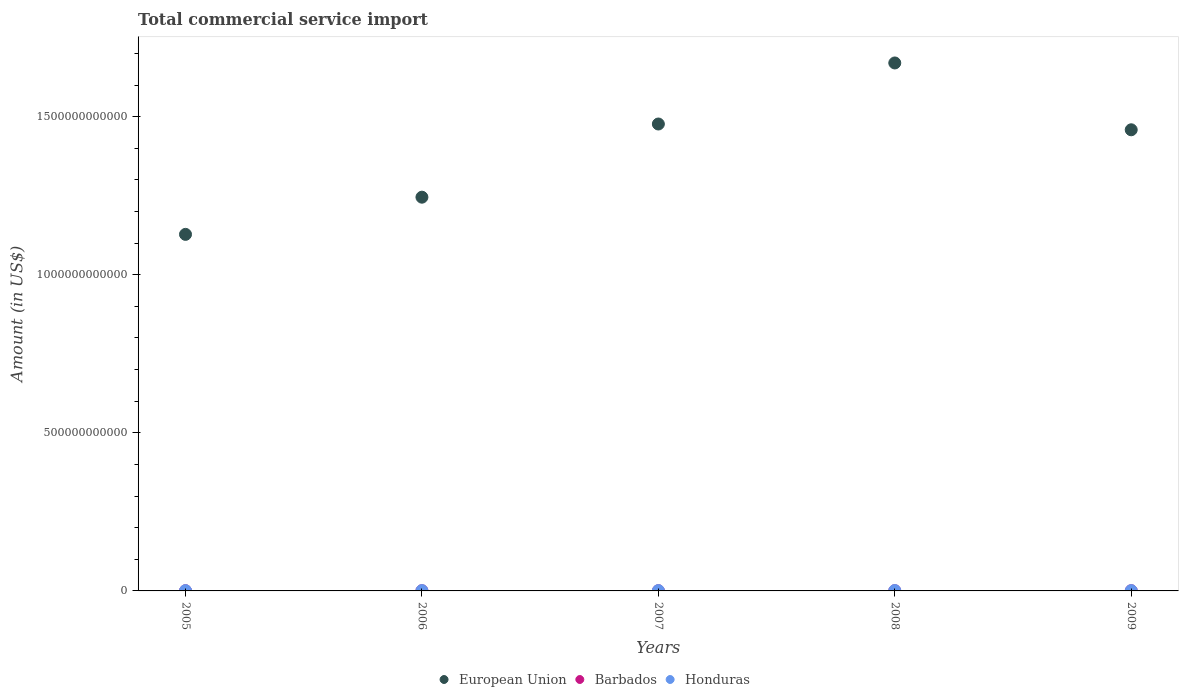What is the total commercial service import in Barbados in 2006?
Your response must be concise. 6.43e+08. Across all years, what is the maximum total commercial service import in European Union?
Ensure brevity in your answer.  1.67e+12. Across all years, what is the minimum total commercial service import in European Union?
Offer a terse response. 1.13e+12. What is the total total commercial service import in Barbados in the graph?
Your answer should be very brief. 3.22e+09. What is the difference between the total commercial service import in European Union in 2007 and that in 2009?
Your answer should be very brief. 1.83e+1. What is the difference between the total commercial service import in Honduras in 2006 and the total commercial service import in Barbados in 2007?
Offer a terse response. 4.20e+08. What is the average total commercial service import in Honduras per year?
Your response must be concise. 1.03e+09. In the year 2008, what is the difference between the total commercial service import in European Union and total commercial service import in Honduras?
Ensure brevity in your answer.  1.67e+12. What is the ratio of the total commercial service import in Honduras in 2008 to that in 2009?
Your response must be concise. 1.29. Is the total commercial service import in European Union in 2006 less than that in 2009?
Give a very brief answer. Yes. What is the difference between the highest and the second highest total commercial service import in Barbados?
Keep it short and to the point. 4.85e+07. What is the difference between the highest and the lowest total commercial service import in European Union?
Offer a very short reply. 5.42e+11. In how many years, is the total commercial service import in Barbados greater than the average total commercial service import in Barbados taken over all years?
Offer a terse response. 2. Is the sum of the total commercial service import in Barbados in 2007 and 2008 greater than the maximum total commercial service import in European Union across all years?
Make the answer very short. No. Is it the case that in every year, the sum of the total commercial service import in European Union and total commercial service import in Barbados  is greater than the total commercial service import in Honduras?
Make the answer very short. Yes. Does the total commercial service import in European Union monotonically increase over the years?
Offer a very short reply. No. Is the total commercial service import in European Union strictly greater than the total commercial service import in Barbados over the years?
Provide a short and direct response. Yes. Is the total commercial service import in Barbados strictly less than the total commercial service import in European Union over the years?
Your response must be concise. Yes. How many years are there in the graph?
Provide a succinct answer. 5. What is the difference between two consecutive major ticks on the Y-axis?
Give a very brief answer. 5.00e+11. What is the title of the graph?
Offer a terse response. Total commercial service import. What is the label or title of the X-axis?
Make the answer very short. Years. What is the label or title of the Y-axis?
Keep it short and to the point. Amount (in US$). What is the Amount (in US$) in European Union in 2005?
Make the answer very short. 1.13e+12. What is the Amount (in US$) of Barbados in 2005?
Ensure brevity in your answer.  6.15e+08. What is the Amount (in US$) of Honduras in 2005?
Provide a succinct answer. 9.24e+08. What is the Amount (in US$) in European Union in 2006?
Your answer should be compact. 1.25e+12. What is the Amount (in US$) in Barbados in 2006?
Offer a very short reply. 6.43e+08. What is the Amount (in US$) of Honduras in 2006?
Keep it short and to the point. 1.03e+09. What is the Amount (in US$) in European Union in 2007?
Ensure brevity in your answer.  1.48e+12. What is the Amount (in US$) of Barbados in 2007?
Offer a very short reply. 6.07e+08. What is the Amount (in US$) in Honduras in 2007?
Offer a very short reply. 1.06e+09. What is the Amount (in US$) of European Union in 2008?
Provide a short and direct response. 1.67e+12. What is the Amount (in US$) of Barbados in 2008?
Provide a short and direct response. 7.00e+08. What is the Amount (in US$) in Honduras in 2008?
Ensure brevity in your answer.  1.21e+09. What is the Amount (in US$) in European Union in 2009?
Keep it short and to the point. 1.46e+12. What is the Amount (in US$) in Barbados in 2009?
Your response must be concise. 6.52e+08. What is the Amount (in US$) of Honduras in 2009?
Offer a terse response. 9.42e+08. Across all years, what is the maximum Amount (in US$) of European Union?
Make the answer very short. 1.67e+12. Across all years, what is the maximum Amount (in US$) in Barbados?
Your response must be concise. 7.00e+08. Across all years, what is the maximum Amount (in US$) of Honduras?
Offer a terse response. 1.21e+09. Across all years, what is the minimum Amount (in US$) of European Union?
Offer a terse response. 1.13e+12. Across all years, what is the minimum Amount (in US$) in Barbados?
Your response must be concise. 6.07e+08. Across all years, what is the minimum Amount (in US$) in Honduras?
Ensure brevity in your answer.  9.24e+08. What is the total Amount (in US$) in European Union in the graph?
Offer a terse response. 6.98e+12. What is the total Amount (in US$) of Barbados in the graph?
Ensure brevity in your answer.  3.22e+09. What is the total Amount (in US$) in Honduras in the graph?
Ensure brevity in your answer.  5.16e+09. What is the difference between the Amount (in US$) in European Union in 2005 and that in 2006?
Make the answer very short. -1.18e+11. What is the difference between the Amount (in US$) of Barbados in 2005 and that in 2006?
Offer a terse response. -2.82e+07. What is the difference between the Amount (in US$) of Honduras in 2005 and that in 2006?
Keep it short and to the point. -1.03e+08. What is the difference between the Amount (in US$) of European Union in 2005 and that in 2007?
Your response must be concise. -3.49e+11. What is the difference between the Amount (in US$) of Barbados in 2005 and that in 2007?
Keep it short and to the point. 7.79e+06. What is the difference between the Amount (in US$) of Honduras in 2005 and that in 2007?
Provide a short and direct response. -1.34e+08. What is the difference between the Amount (in US$) in European Union in 2005 and that in 2008?
Offer a terse response. -5.42e+11. What is the difference between the Amount (in US$) in Barbados in 2005 and that in 2008?
Your response must be concise. -8.54e+07. What is the difference between the Amount (in US$) in Honduras in 2005 and that in 2008?
Ensure brevity in your answer.  -2.90e+08. What is the difference between the Amount (in US$) in European Union in 2005 and that in 2009?
Offer a very short reply. -3.31e+11. What is the difference between the Amount (in US$) of Barbados in 2005 and that in 2009?
Your response must be concise. -3.69e+07. What is the difference between the Amount (in US$) of Honduras in 2005 and that in 2009?
Provide a short and direct response. -1.88e+07. What is the difference between the Amount (in US$) in European Union in 2006 and that in 2007?
Give a very brief answer. -2.31e+11. What is the difference between the Amount (in US$) in Barbados in 2006 and that in 2007?
Give a very brief answer. 3.60e+07. What is the difference between the Amount (in US$) in Honduras in 2006 and that in 2007?
Provide a short and direct response. -3.11e+07. What is the difference between the Amount (in US$) of European Union in 2006 and that in 2008?
Offer a terse response. -4.25e+11. What is the difference between the Amount (in US$) of Barbados in 2006 and that in 2008?
Your answer should be compact. -5.72e+07. What is the difference between the Amount (in US$) in Honduras in 2006 and that in 2008?
Your answer should be compact. -1.86e+08. What is the difference between the Amount (in US$) in European Union in 2006 and that in 2009?
Give a very brief answer. -2.13e+11. What is the difference between the Amount (in US$) in Barbados in 2006 and that in 2009?
Your answer should be very brief. -8.71e+06. What is the difference between the Amount (in US$) of Honduras in 2006 and that in 2009?
Ensure brevity in your answer.  8.46e+07. What is the difference between the Amount (in US$) of European Union in 2007 and that in 2008?
Provide a succinct answer. -1.93e+11. What is the difference between the Amount (in US$) in Barbados in 2007 and that in 2008?
Provide a short and direct response. -9.32e+07. What is the difference between the Amount (in US$) in Honduras in 2007 and that in 2008?
Ensure brevity in your answer.  -1.55e+08. What is the difference between the Amount (in US$) in European Union in 2007 and that in 2009?
Offer a terse response. 1.83e+1. What is the difference between the Amount (in US$) in Barbados in 2007 and that in 2009?
Provide a succinct answer. -4.47e+07. What is the difference between the Amount (in US$) of Honduras in 2007 and that in 2009?
Make the answer very short. 1.16e+08. What is the difference between the Amount (in US$) in European Union in 2008 and that in 2009?
Offer a very short reply. 2.11e+11. What is the difference between the Amount (in US$) in Barbados in 2008 and that in 2009?
Offer a very short reply. 4.85e+07. What is the difference between the Amount (in US$) of Honduras in 2008 and that in 2009?
Your answer should be very brief. 2.71e+08. What is the difference between the Amount (in US$) of European Union in 2005 and the Amount (in US$) of Barbados in 2006?
Offer a very short reply. 1.13e+12. What is the difference between the Amount (in US$) of European Union in 2005 and the Amount (in US$) of Honduras in 2006?
Ensure brevity in your answer.  1.13e+12. What is the difference between the Amount (in US$) in Barbados in 2005 and the Amount (in US$) in Honduras in 2006?
Your answer should be compact. -4.12e+08. What is the difference between the Amount (in US$) of European Union in 2005 and the Amount (in US$) of Barbados in 2007?
Keep it short and to the point. 1.13e+12. What is the difference between the Amount (in US$) of European Union in 2005 and the Amount (in US$) of Honduras in 2007?
Ensure brevity in your answer.  1.13e+12. What is the difference between the Amount (in US$) in Barbados in 2005 and the Amount (in US$) in Honduras in 2007?
Ensure brevity in your answer.  -4.43e+08. What is the difference between the Amount (in US$) of European Union in 2005 and the Amount (in US$) of Barbados in 2008?
Provide a short and direct response. 1.13e+12. What is the difference between the Amount (in US$) in European Union in 2005 and the Amount (in US$) in Honduras in 2008?
Provide a short and direct response. 1.13e+12. What is the difference between the Amount (in US$) in Barbados in 2005 and the Amount (in US$) in Honduras in 2008?
Your answer should be very brief. -5.98e+08. What is the difference between the Amount (in US$) of European Union in 2005 and the Amount (in US$) of Barbados in 2009?
Keep it short and to the point. 1.13e+12. What is the difference between the Amount (in US$) in European Union in 2005 and the Amount (in US$) in Honduras in 2009?
Your answer should be very brief. 1.13e+12. What is the difference between the Amount (in US$) of Barbados in 2005 and the Amount (in US$) of Honduras in 2009?
Your response must be concise. -3.27e+08. What is the difference between the Amount (in US$) of European Union in 2006 and the Amount (in US$) of Barbados in 2007?
Your answer should be compact. 1.24e+12. What is the difference between the Amount (in US$) in European Union in 2006 and the Amount (in US$) in Honduras in 2007?
Provide a short and direct response. 1.24e+12. What is the difference between the Amount (in US$) in Barbados in 2006 and the Amount (in US$) in Honduras in 2007?
Give a very brief answer. -4.15e+08. What is the difference between the Amount (in US$) in European Union in 2006 and the Amount (in US$) in Barbados in 2008?
Provide a short and direct response. 1.24e+12. What is the difference between the Amount (in US$) of European Union in 2006 and the Amount (in US$) of Honduras in 2008?
Make the answer very short. 1.24e+12. What is the difference between the Amount (in US$) of Barbados in 2006 and the Amount (in US$) of Honduras in 2008?
Your answer should be very brief. -5.70e+08. What is the difference between the Amount (in US$) of European Union in 2006 and the Amount (in US$) of Barbados in 2009?
Offer a terse response. 1.24e+12. What is the difference between the Amount (in US$) in European Union in 2006 and the Amount (in US$) in Honduras in 2009?
Ensure brevity in your answer.  1.24e+12. What is the difference between the Amount (in US$) of Barbados in 2006 and the Amount (in US$) of Honduras in 2009?
Ensure brevity in your answer.  -2.99e+08. What is the difference between the Amount (in US$) of European Union in 2007 and the Amount (in US$) of Barbados in 2008?
Ensure brevity in your answer.  1.48e+12. What is the difference between the Amount (in US$) in European Union in 2007 and the Amount (in US$) in Honduras in 2008?
Your response must be concise. 1.48e+12. What is the difference between the Amount (in US$) in Barbados in 2007 and the Amount (in US$) in Honduras in 2008?
Ensure brevity in your answer.  -6.06e+08. What is the difference between the Amount (in US$) in European Union in 2007 and the Amount (in US$) in Barbados in 2009?
Give a very brief answer. 1.48e+12. What is the difference between the Amount (in US$) in European Union in 2007 and the Amount (in US$) in Honduras in 2009?
Give a very brief answer. 1.48e+12. What is the difference between the Amount (in US$) of Barbados in 2007 and the Amount (in US$) of Honduras in 2009?
Offer a terse response. -3.35e+08. What is the difference between the Amount (in US$) of European Union in 2008 and the Amount (in US$) of Barbados in 2009?
Keep it short and to the point. 1.67e+12. What is the difference between the Amount (in US$) in European Union in 2008 and the Amount (in US$) in Honduras in 2009?
Make the answer very short. 1.67e+12. What is the difference between the Amount (in US$) of Barbados in 2008 and the Amount (in US$) of Honduras in 2009?
Your answer should be compact. -2.42e+08. What is the average Amount (in US$) of European Union per year?
Offer a very short reply. 1.40e+12. What is the average Amount (in US$) of Barbados per year?
Your answer should be very brief. 6.44e+08. What is the average Amount (in US$) of Honduras per year?
Keep it short and to the point. 1.03e+09. In the year 2005, what is the difference between the Amount (in US$) in European Union and Amount (in US$) in Barbados?
Your answer should be compact. 1.13e+12. In the year 2005, what is the difference between the Amount (in US$) of European Union and Amount (in US$) of Honduras?
Give a very brief answer. 1.13e+12. In the year 2005, what is the difference between the Amount (in US$) of Barbados and Amount (in US$) of Honduras?
Your response must be concise. -3.09e+08. In the year 2006, what is the difference between the Amount (in US$) of European Union and Amount (in US$) of Barbados?
Ensure brevity in your answer.  1.24e+12. In the year 2006, what is the difference between the Amount (in US$) in European Union and Amount (in US$) in Honduras?
Keep it short and to the point. 1.24e+12. In the year 2006, what is the difference between the Amount (in US$) in Barbados and Amount (in US$) in Honduras?
Ensure brevity in your answer.  -3.84e+08. In the year 2007, what is the difference between the Amount (in US$) of European Union and Amount (in US$) of Barbados?
Provide a succinct answer. 1.48e+12. In the year 2007, what is the difference between the Amount (in US$) in European Union and Amount (in US$) in Honduras?
Provide a succinct answer. 1.48e+12. In the year 2007, what is the difference between the Amount (in US$) in Barbados and Amount (in US$) in Honduras?
Keep it short and to the point. -4.51e+08. In the year 2008, what is the difference between the Amount (in US$) of European Union and Amount (in US$) of Barbados?
Your answer should be compact. 1.67e+12. In the year 2008, what is the difference between the Amount (in US$) in European Union and Amount (in US$) in Honduras?
Provide a short and direct response. 1.67e+12. In the year 2008, what is the difference between the Amount (in US$) in Barbados and Amount (in US$) in Honduras?
Your answer should be very brief. -5.13e+08. In the year 2009, what is the difference between the Amount (in US$) of European Union and Amount (in US$) of Barbados?
Provide a short and direct response. 1.46e+12. In the year 2009, what is the difference between the Amount (in US$) of European Union and Amount (in US$) of Honduras?
Your answer should be very brief. 1.46e+12. In the year 2009, what is the difference between the Amount (in US$) in Barbados and Amount (in US$) in Honduras?
Keep it short and to the point. -2.90e+08. What is the ratio of the Amount (in US$) of European Union in 2005 to that in 2006?
Your response must be concise. 0.91. What is the ratio of the Amount (in US$) of Barbados in 2005 to that in 2006?
Offer a terse response. 0.96. What is the ratio of the Amount (in US$) of Honduras in 2005 to that in 2006?
Provide a succinct answer. 0.9. What is the ratio of the Amount (in US$) of European Union in 2005 to that in 2007?
Make the answer very short. 0.76. What is the ratio of the Amount (in US$) in Barbados in 2005 to that in 2007?
Give a very brief answer. 1.01. What is the ratio of the Amount (in US$) of Honduras in 2005 to that in 2007?
Your answer should be very brief. 0.87. What is the ratio of the Amount (in US$) in European Union in 2005 to that in 2008?
Offer a very short reply. 0.68. What is the ratio of the Amount (in US$) in Barbados in 2005 to that in 2008?
Provide a succinct answer. 0.88. What is the ratio of the Amount (in US$) of Honduras in 2005 to that in 2008?
Your response must be concise. 0.76. What is the ratio of the Amount (in US$) of European Union in 2005 to that in 2009?
Make the answer very short. 0.77. What is the ratio of the Amount (in US$) of Barbados in 2005 to that in 2009?
Your answer should be compact. 0.94. What is the ratio of the Amount (in US$) of Honduras in 2005 to that in 2009?
Offer a very short reply. 0.98. What is the ratio of the Amount (in US$) in European Union in 2006 to that in 2007?
Offer a very short reply. 0.84. What is the ratio of the Amount (in US$) of Barbados in 2006 to that in 2007?
Ensure brevity in your answer.  1.06. What is the ratio of the Amount (in US$) in Honduras in 2006 to that in 2007?
Your answer should be compact. 0.97. What is the ratio of the Amount (in US$) in European Union in 2006 to that in 2008?
Your answer should be compact. 0.75. What is the ratio of the Amount (in US$) in Barbados in 2006 to that in 2008?
Provide a succinct answer. 0.92. What is the ratio of the Amount (in US$) of Honduras in 2006 to that in 2008?
Give a very brief answer. 0.85. What is the ratio of the Amount (in US$) in European Union in 2006 to that in 2009?
Your answer should be very brief. 0.85. What is the ratio of the Amount (in US$) in Barbados in 2006 to that in 2009?
Provide a succinct answer. 0.99. What is the ratio of the Amount (in US$) in Honduras in 2006 to that in 2009?
Keep it short and to the point. 1.09. What is the ratio of the Amount (in US$) in European Union in 2007 to that in 2008?
Ensure brevity in your answer.  0.88. What is the ratio of the Amount (in US$) of Barbados in 2007 to that in 2008?
Your answer should be very brief. 0.87. What is the ratio of the Amount (in US$) in Honduras in 2007 to that in 2008?
Offer a very short reply. 0.87. What is the ratio of the Amount (in US$) in European Union in 2007 to that in 2009?
Your answer should be very brief. 1.01. What is the ratio of the Amount (in US$) in Barbados in 2007 to that in 2009?
Provide a short and direct response. 0.93. What is the ratio of the Amount (in US$) of Honduras in 2007 to that in 2009?
Offer a terse response. 1.12. What is the ratio of the Amount (in US$) in European Union in 2008 to that in 2009?
Make the answer very short. 1.14. What is the ratio of the Amount (in US$) in Barbados in 2008 to that in 2009?
Give a very brief answer. 1.07. What is the ratio of the Amount (in US$) of Honduras in 2008 to that in 2009?
Make the answer very short. 1.29. What is the difference between the highest and the second highest Amount (in US$) in European Union?
Give a very brief answer. 1.93e+11. What is the difference between the highest and the second highest Amount (in US$) in Barbados?
Your answer should be compact. 4.85e+07. What is the difference between the highest and the second highest Amount (in US$) in Honduras?
Provide a short and direct response. 1.55e+08. What is the difference between the highest and the lowest Amount (in US$) of European Union?
Offer a very short reply. 5.42e+11. What is the difference between the highest and the lowest Amount (in US$) in Barbados?
Give a very brief answer. 9.32e+07. What is the difference between the highest and the lowest Amount (in US$) of Honduras?
Your answer should be compact. 2.90e+08. 